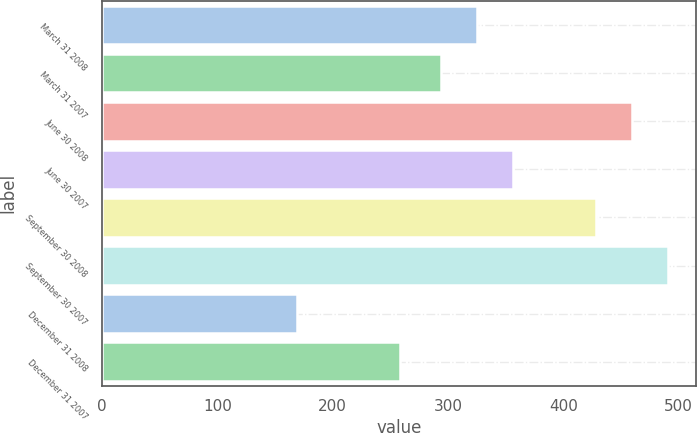Convert chart to OTSL. <chart><loc_0><loc_0><loc_500><loc_500><bar_chart><fcel>March 31 2008<fcel>March 31 2007<fcel>June 30 2008<fcel>June 30 2007<fcel>September 30 2008<fcel>September 30 2007<fcel>December 31 2008<fcel>December 31 2007<nl><fcel>325.2<fcel>294<fcel>459.2<fcel>356.4<fcel>428<fcel>490.4<fcel>169<fcel>258<nl></chart> 